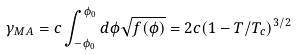<formula> <loc_0><loc_0><loc_500><loc_500>\gamma _ { M A } = c \int ^ { \phi _ { 0 } } _ { - \phi _ { 0 } } d \phi \sqrt { f ( \phi ) } = 2 c ( 1 - T / T _ { c } ) ^ { 3 / 2 }</formula> 